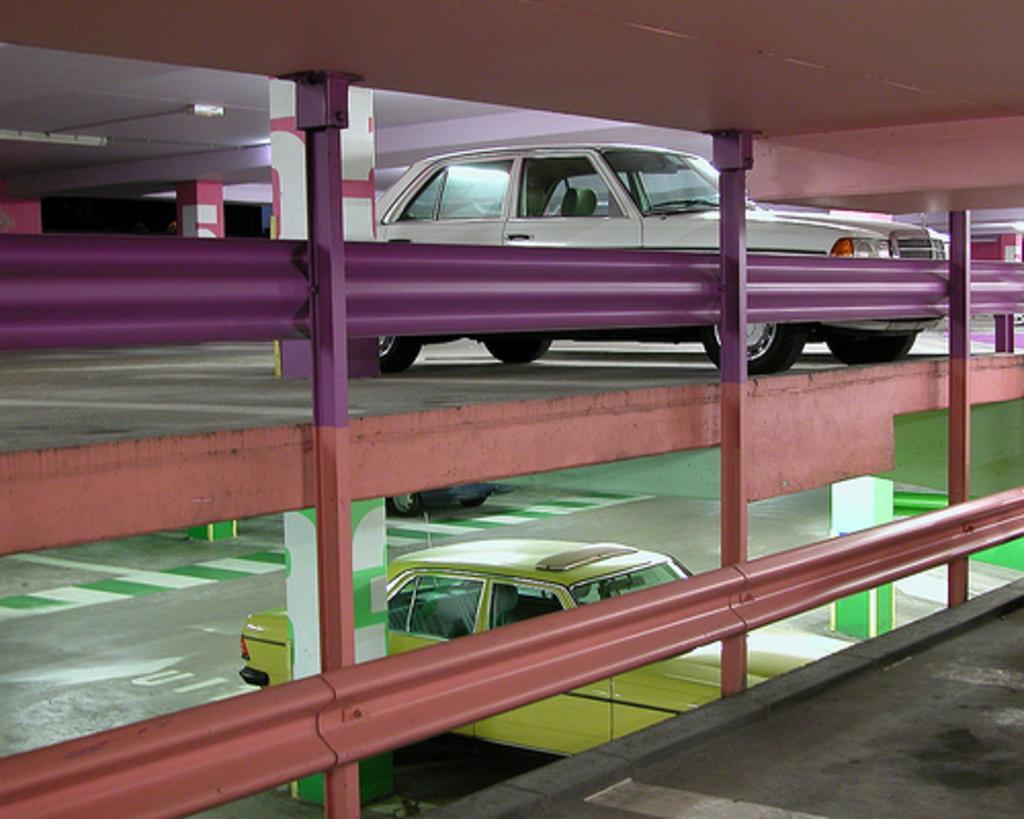Can you describe this image briefly? In this picture there is a white car which is parked on this floor. At the bottom I can see the yellow color car which is parked near to the pillars. In the center I can see the fencing. In the top left corner I can see the tube light which is placed on the roof. 